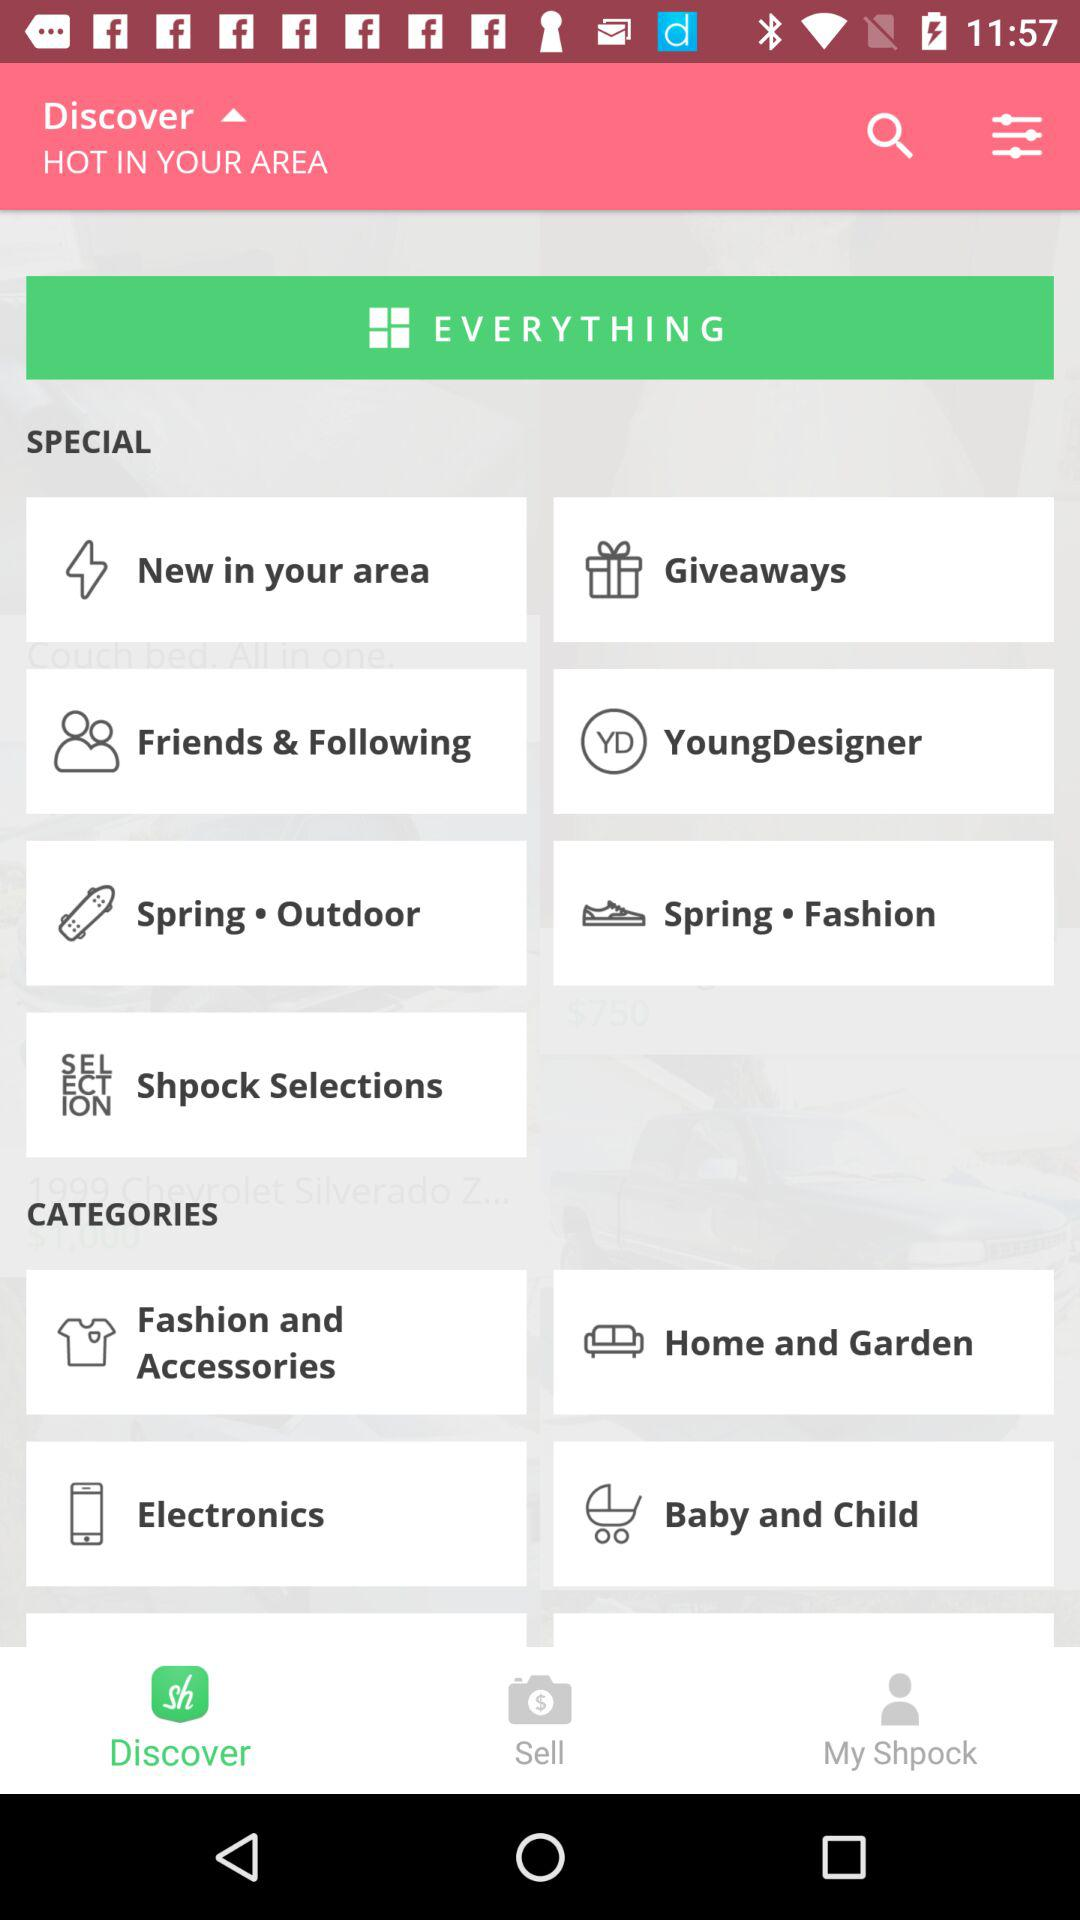What are the names of the categories? The names of the categories are "Fashion and Accessories", "Home and Garden", "Electronics" and "Baby and Child". 